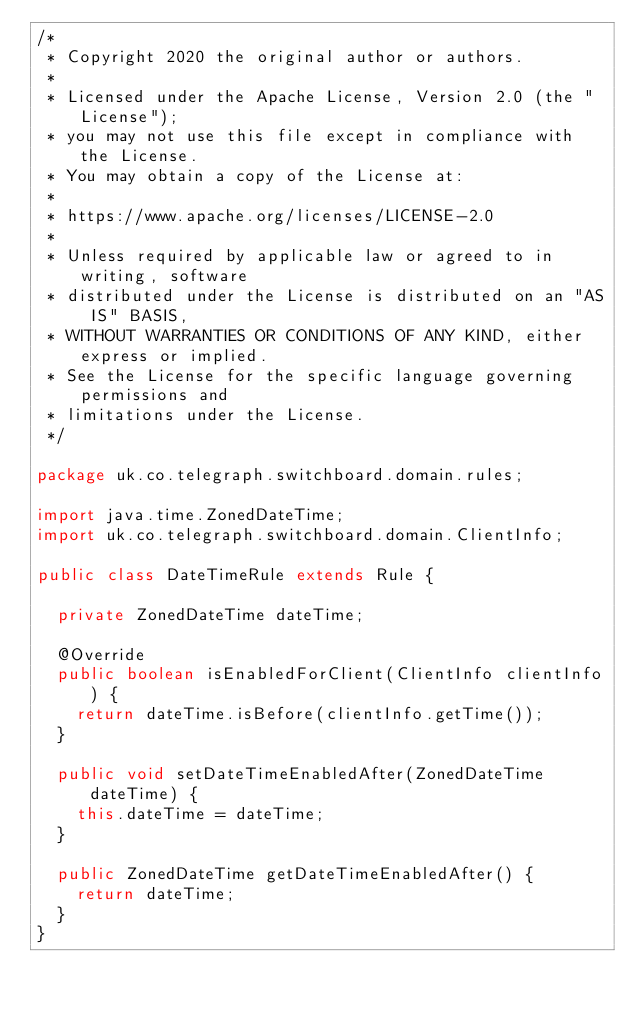Convert code to text. <code><loc_0><loc_0><loc_500><loc_500><_Java_>/*
 * Copyright 2020 the original author or authors.
 *
 * Licensed under the Apache License, Version 2.0 (the "License");
 * you may not use this file except in compliance with the License.
 * You may obtain a copy of the License at:
 *
 * https://www.apache.org/licenses/LICENSE-2.0
 *
 * Unless required by applicable law or agreed to in writing, software
 * distributed under the License is distributed on an "AS IS" BASIS,
 * WITHOUT WARRANTIES OR CONDITIONS OF ANY KIND, either express or implied.
 * See the License for the specific language governing permissions and
 * limitations under the License.
 */

package uk.co.telegraph.switchboard.domain.rules;

import java.time.ZonedDateTime;
import uk.co.telegraph.switchboard.domain.ClientInfo;

public class DateTimeRule extends Rule {

  private ZonedDateTime dateTime;

  @Override
  public boolean isEnabledForClient(ClientInfo clientInfo) {
    return dateTime.isBefore(clientInfo.getTime());
  }

  public void setDateTimeEnabledAfter(ZonedDateTime dateTime) {
    this.dateTime = dateTime;
  }

  public ZonedDateTime getDateTimeEnabledAfter() {
    return dateTime;
  }
}
</code> 